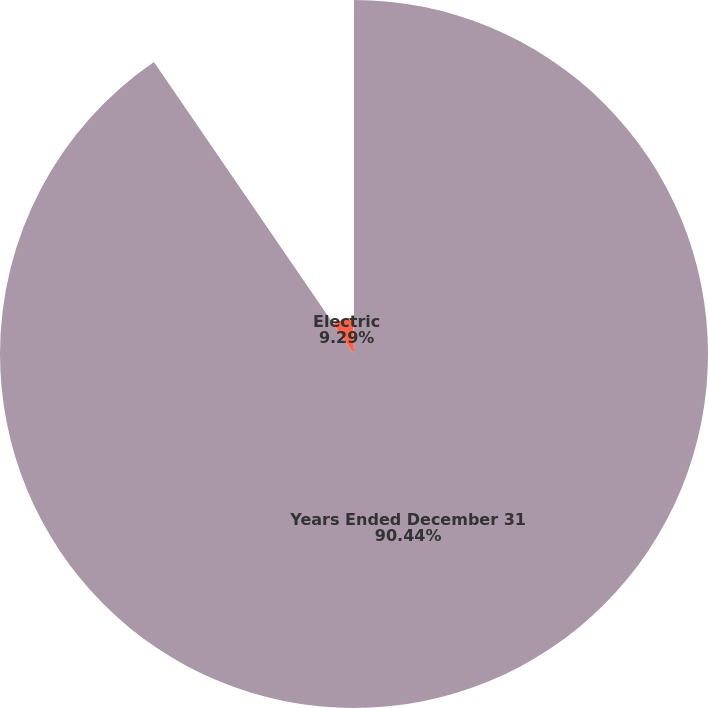Convert chart to OTSL. <chart><loc_0><loc_0><loc_500><loc_500><pie_chart><fcel>Years Ended December 31<fcel>Electric<fcel>Gas<nl><fcel>90.44%<fcel>9.29%<fcel>0.27%<nl></chart> 